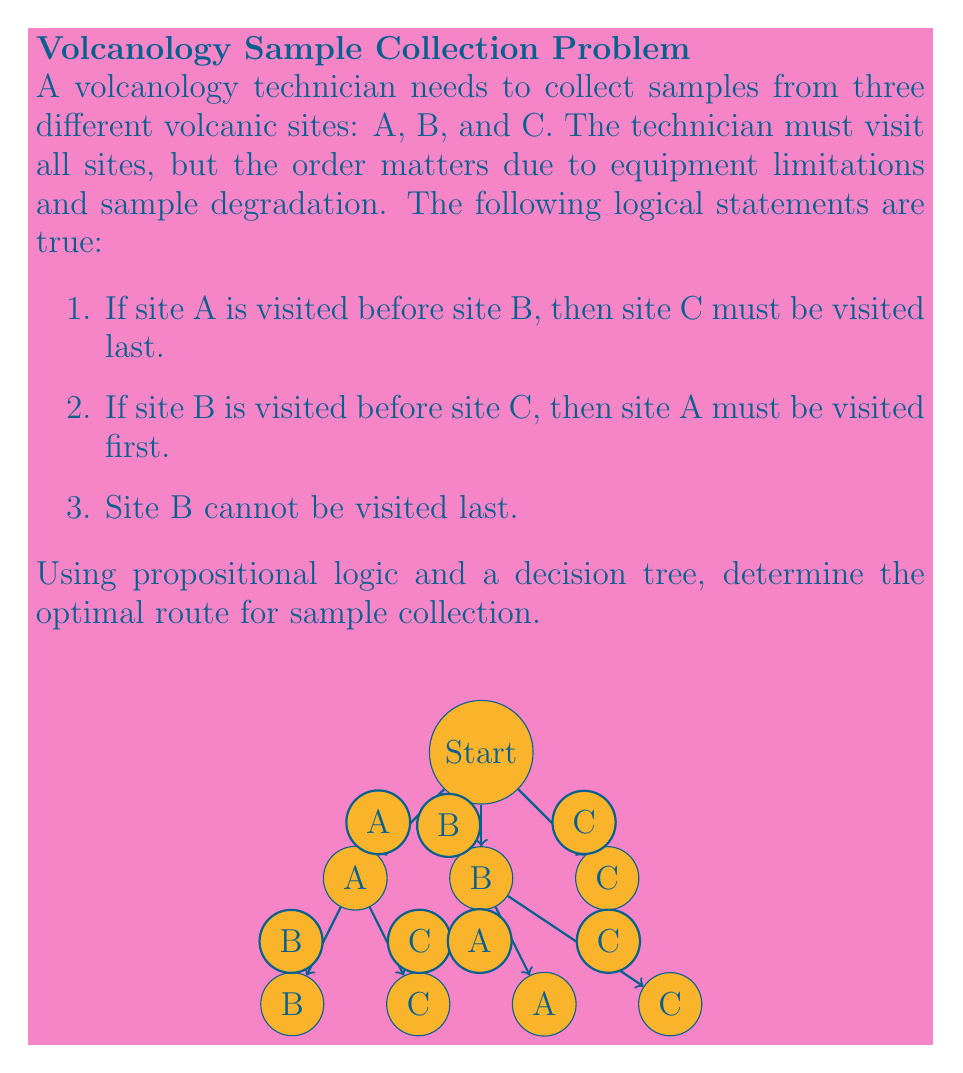Teach me how to tackle this problem. Let's approach this step-by-step using propositional logic and the decision tree:

1) Let's define our propositions:
   $A_f$: Site A is visited first
   $B_f$: Site B is visited first
   $C_f$: Site C is visited first
   $A_l$: Site A is visited last
   $B_l$: Site B is visited last
   $C_l$: Site C is visited last

2) From the given statements, we can derive:
   Statement 1: $A \rightarrow B \implies C_l$
   Statement 2: $B \rightarrow C \implies A_f$
   Statement 3: $\neg B_l$

3) Using the decision tree, we can eliminate impossible routes:

   - If we start with A:
     - We can't go A → B → C (violates statement 1)
     - A → C → B is possible

   - If we start with B:
     - B → A → C (violates statement 2)
     - B → C → A is possible

   - If we start with C:
     - C → A → B is possible
     - C → B → A (violates statement 3)

4) We're left with three possible routes:
   A → C → B
   B → C → A
   C → A → B

5) However, statement 2 implies that if B is before C, A must be first. This eliminates B → C → A.

6) We're left with two valid routes:
   A → C → B
   C → A → B

Both of these routes satisfy all the given conditions. Since no additional information is provided about the efficiency or preference of these routes, both can be considered optimal.
Answer: A → C → B or C → A → B 